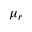<formula> <loc_0><loc_0><loc_500><loc_500>\mu _ { r }</formula> 